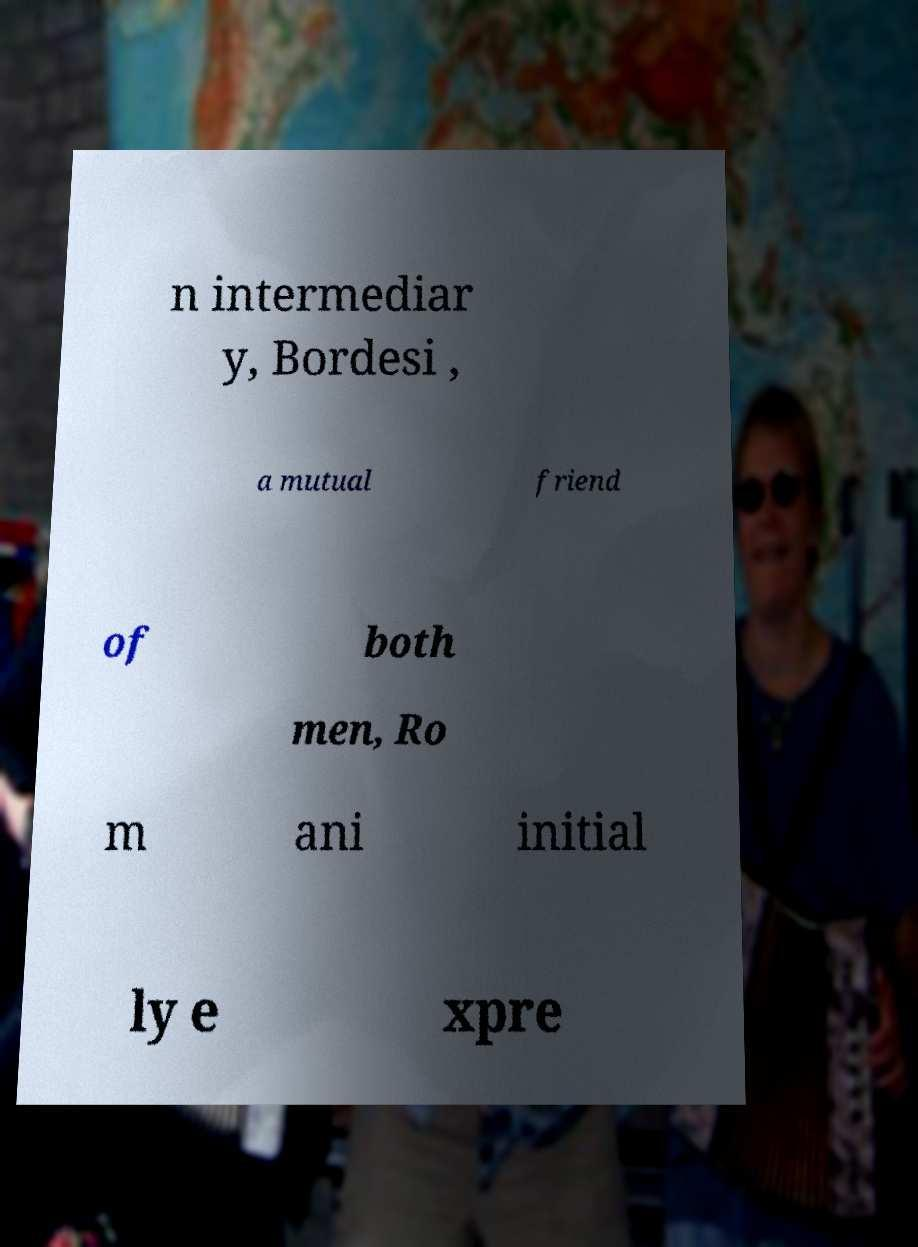For documentation purposes, I need the text within this image transcribed. Could you provide that? n intermediar y, Bordesi , a mutual friend of both men, Ro m ani initial ly e xpre 